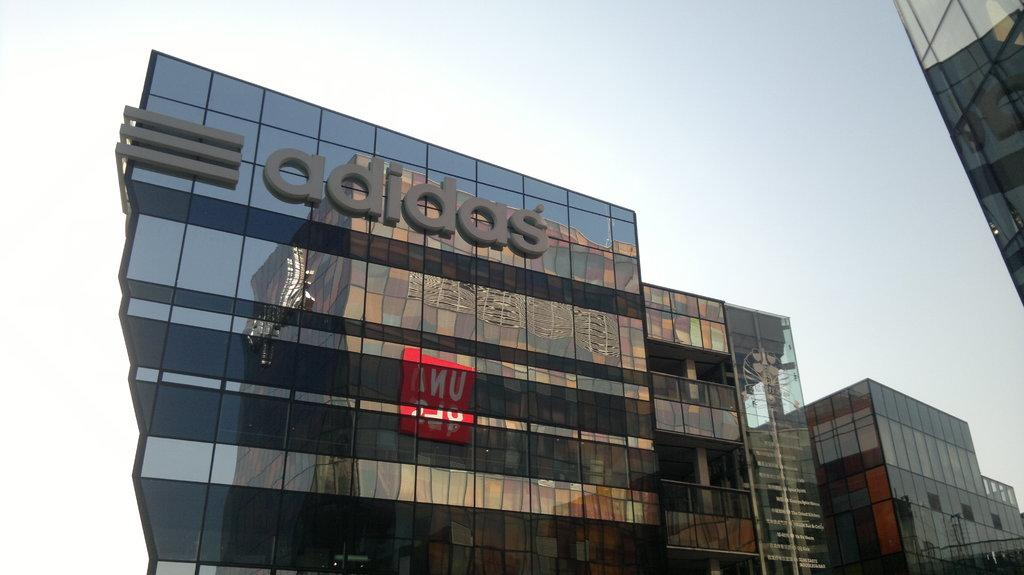What type of structures can be seen in the image? There are buildings in the image. What additional features are present on the buildings? There are name boards on the buildings. What can be seen in the background of the image? The sky is visible in the image. What type of rhythm can be heard coming from the bed in the image? There is no bed present in the image, so it is not possible to determine any rhythm associated with it. 